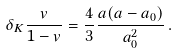<formula> <loc_0><loc_0><loc_500><loc_500>\delta _ { K } \frac { v } { 1 - v } = \frac { 4 } { 3 } \frac { a ( a - a _ { 0 } ) } { a _ { 0 } ^ { 2 } } \, .</formula> 